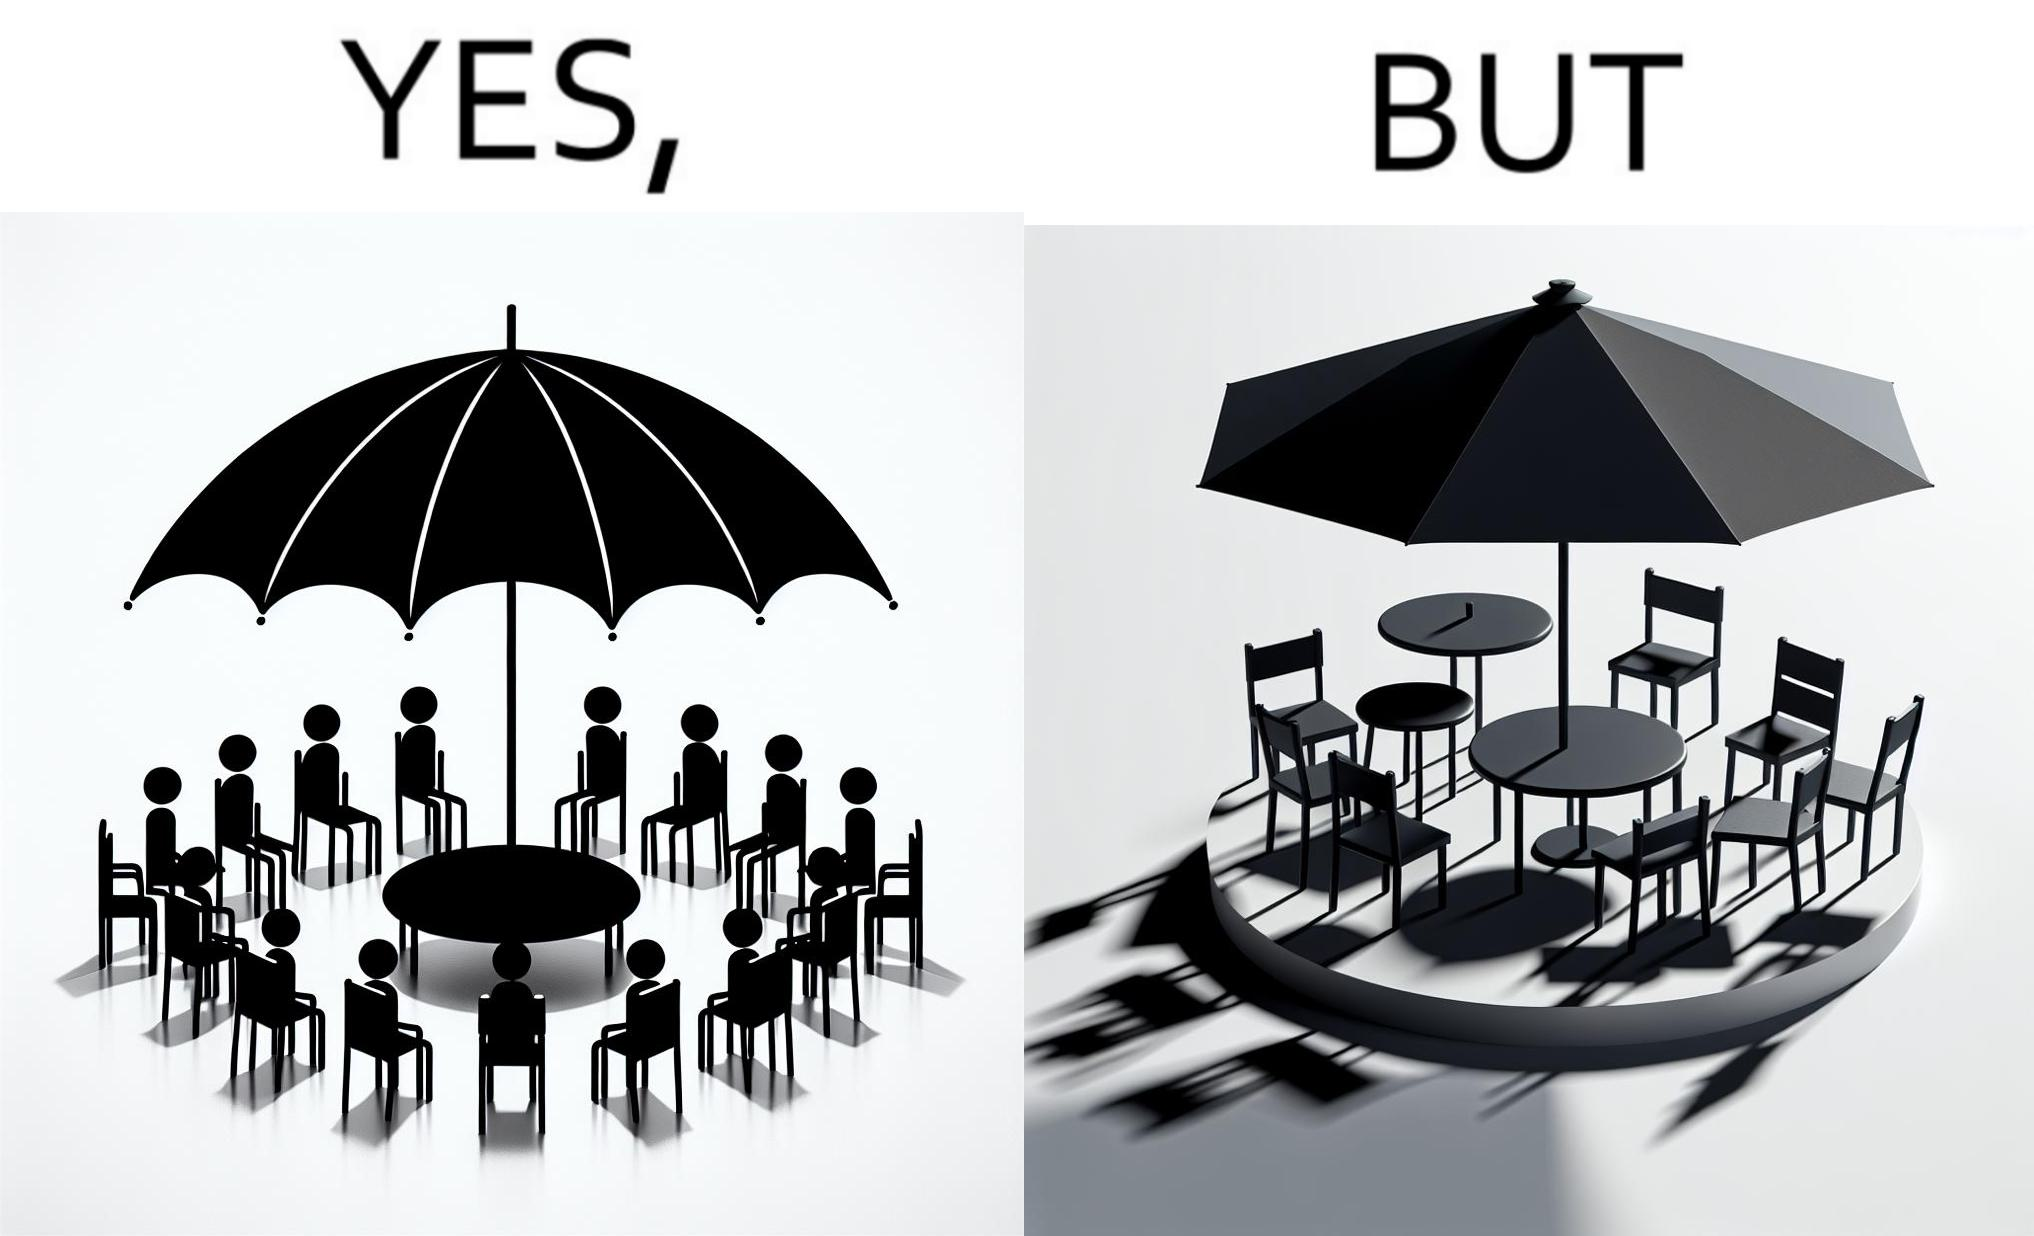Describe the satirical element in this image. The image is ironical, as the umbrella is meant to provide shadow in the area where the chairs are present, but due to the orientation of the rays of the sun, all the chairs are in sunlight, and the umbrella is of no use in this situation. 